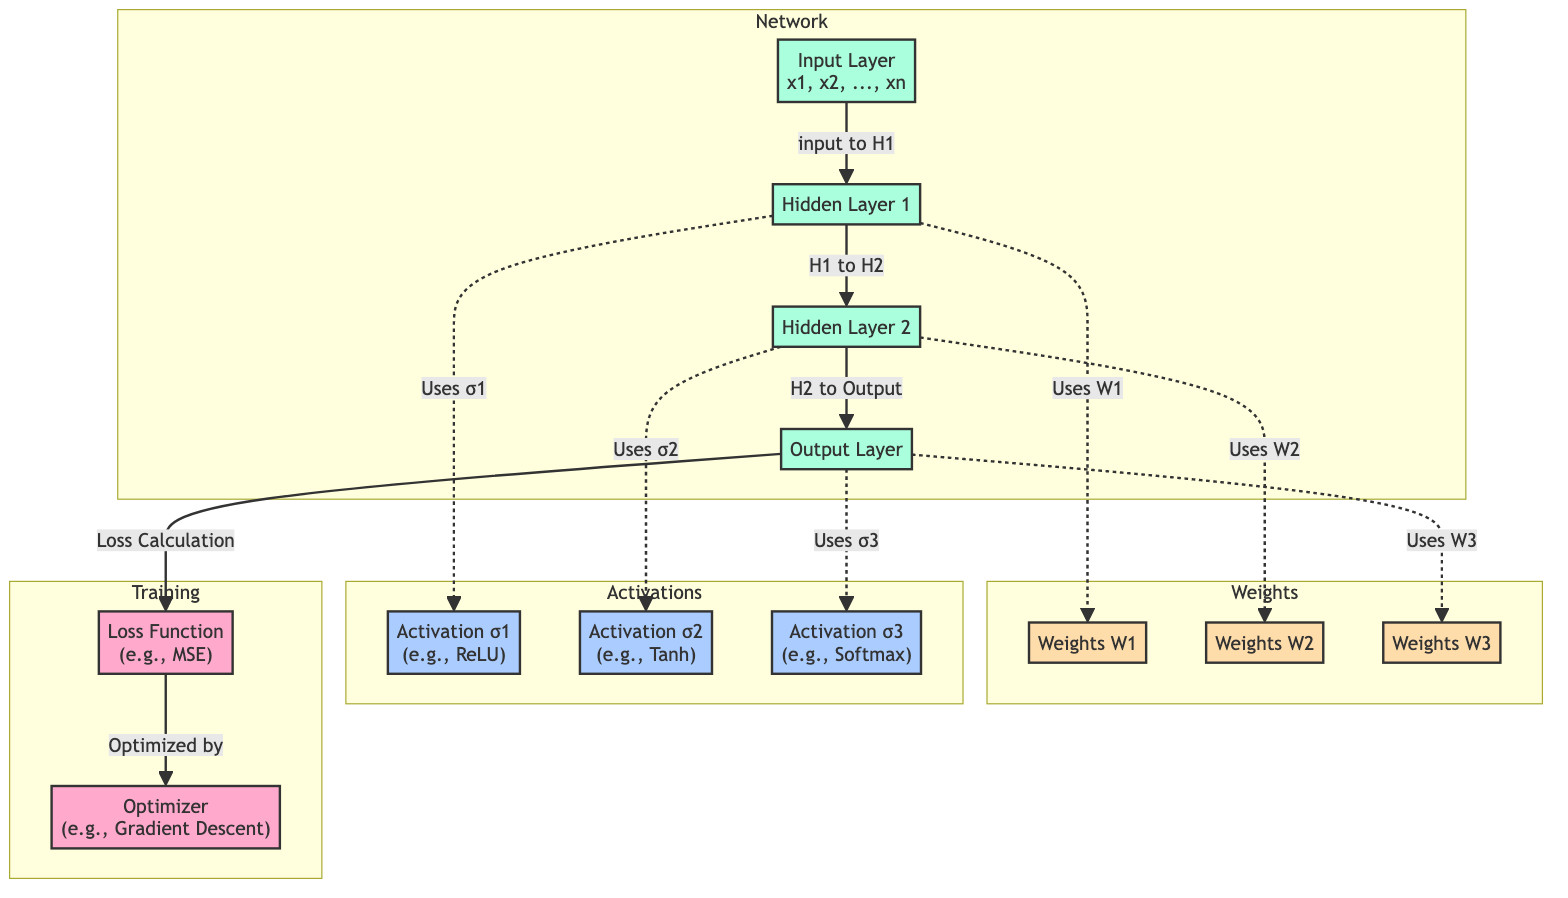What are the layers present in this architecture? The diagram identifies three main layers: the input layer, hidden layer 1, hidden layer 2, and the output layer. These layers are explicitly labeled in the diagram.
Answer: input layer, hidden layer 1, hidden layer 2, output layer What types of activation functions are used? The diagram indicates three activation functions: σ1 for hidden layer 1, σ2 for hidden layer 2, and σ3 for the output layer. These are highlighted in their respective sections.
Answer: ReLU, Tanh, Softmax How many weights are utilized in the diagram? The diagram shows three weights: W1 for hidden layer 1, W2 for hidden layer 2, and W3 for the output layer. Each weight is connected to the corresponding layer, as shown in the design.
Answer: 3 What is the relationship between the output layer and the loss function? The output layer connects to the loss function through a directed edge labeled "Loss Calculation." This indicates that the output of the model is processed by the loss function for evaluation.
Answer: Loss Calculation Which optimizer is used in the training process? Within the training section of the diagram, the optimizer is labeled as "Optimizer (e.g., Gradient Descent)," making it clear which method is applied during the training phase.
Answer: Gradient Descent What purpose do the weights W1, W2, and W3 serve? Each weight in the diagram is indicated to be used by its respective layer: W1 is for hidden layer 1, W2 for hidden layer 2, and W3 for the output layer, signifying their roles in connecting the layers.
Answer: Connecting layers How does the information flow from the input layer to the output layer? The diagram demonstrates a sequential flow: input layer to hidden layer 1, hidden layer 1 to hidden layer 2, and hidden layer 2 to output layer, depicting a clear progression of data through the layers.
Answer: Sequential flow What type of loss function is indicated in the diagram? The loss function in the diagram is noted as "Loss Function (e.g., MSE)," which is explicitly mentioned in the training section of the diagram.
Answer: Mean Squared Error What is the output of the second hidden layer? In the diagram, the second hidden layer utilizes activation σ2 before passing its result to the output layer, indicating that the second hidden layer's output is processed through an activation function.
Answer: σ2 output 